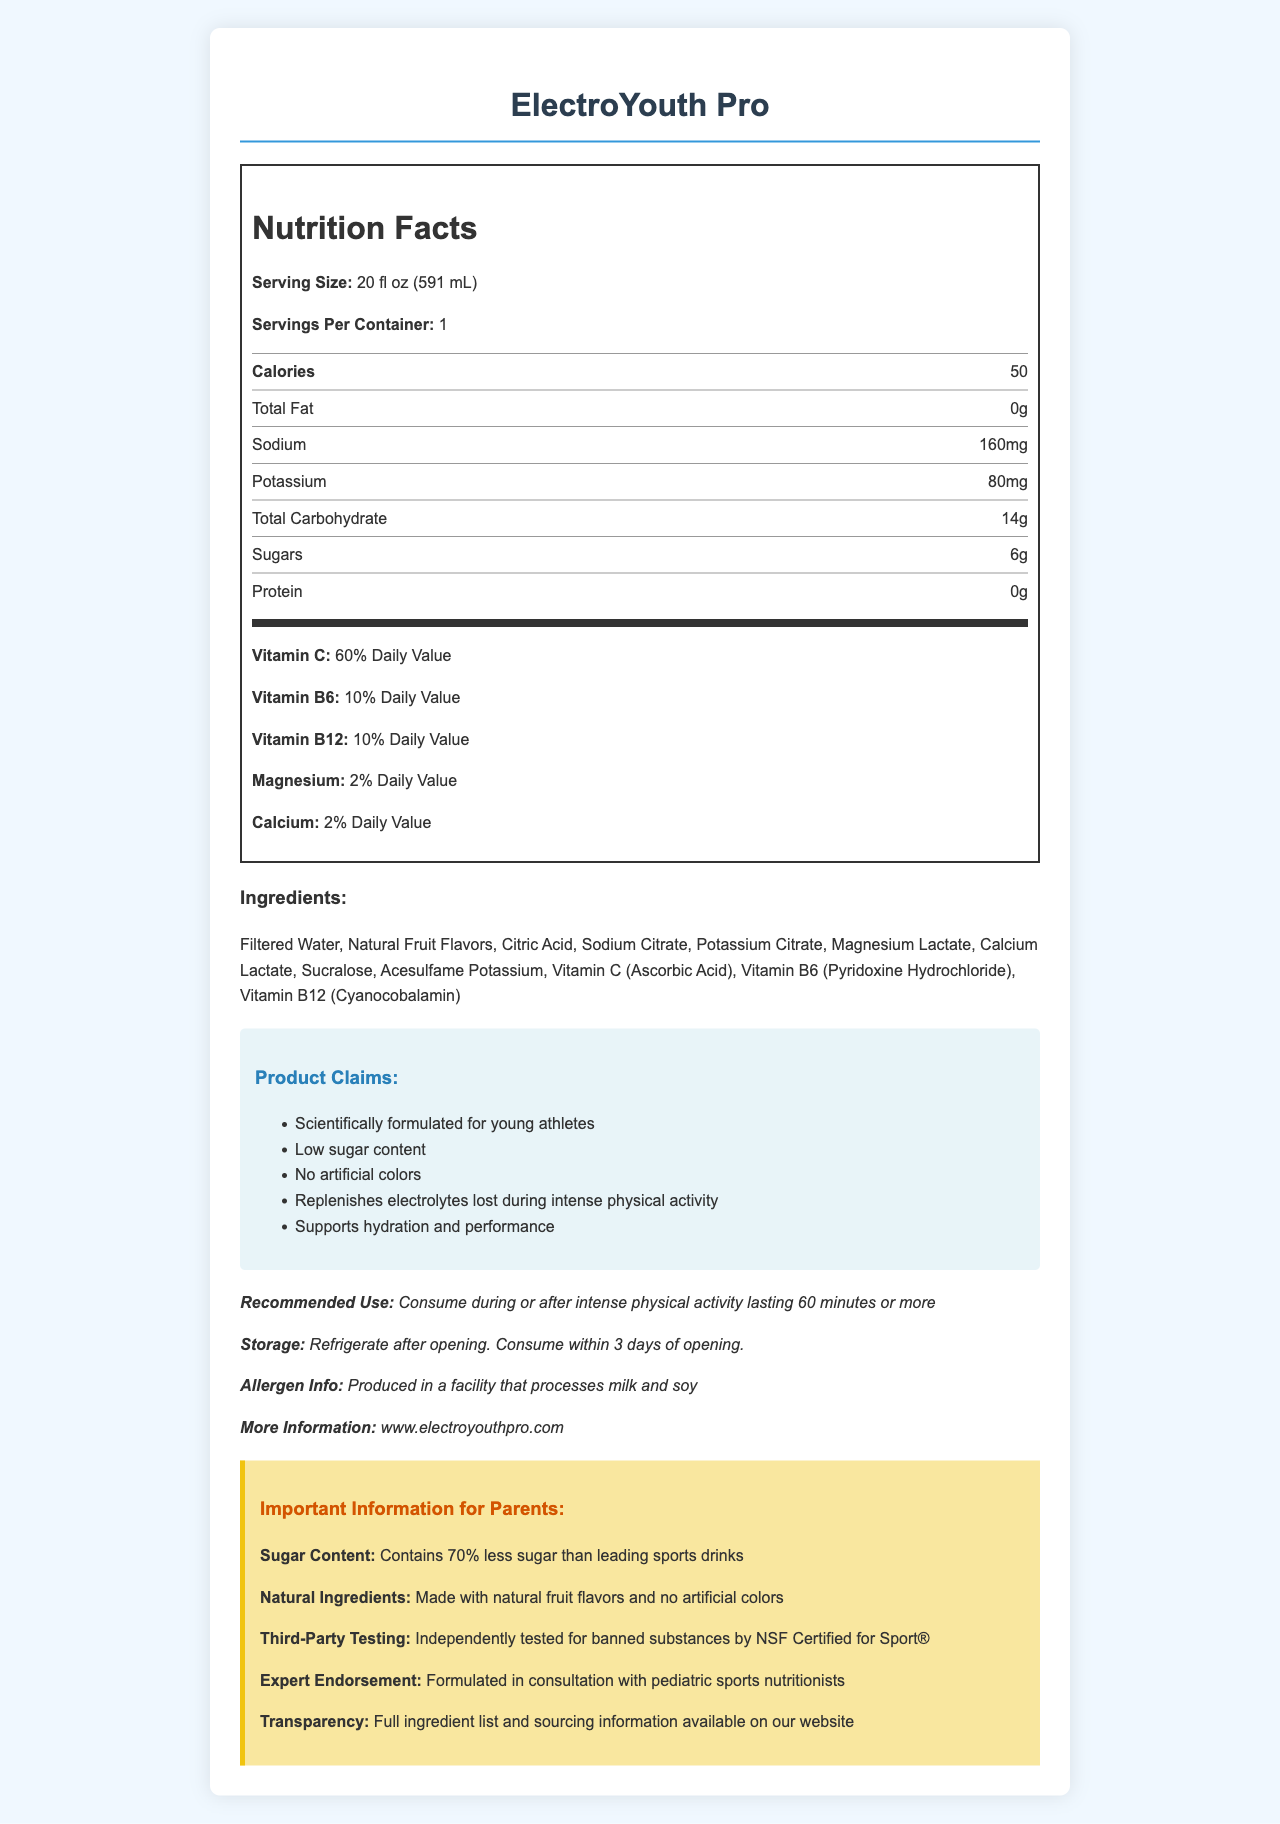what is the serving size? The serving size is listed at the beginning of the nutrition label section.
Answer: 20 fl oz (591 mL) How many servings per container are there? The document specifies that there is 1 serving per container.
Answer: 1 What is the total calorie content per serving? The total calorie content per serving is listed under the nutrition facts section.
Answer: 50 What are the main electrolytes in ElectroYouth Pro? Sodium (160mg) and Potassium (80mg) are listed under the nutrition facts in the nutrition label.
Answer: Sodium and Potassium How much sugar does ElectroYouth Pro contain? The document states that there are 6 grams of sugar per serving.
Answer: 6g What percentage of the daily value of Vitamin C does one serving provide? The Vitamin C content is listed as 60% of the Daily Value in the nutrition facts.
Answer: 60% What is the recommended use for ElectroYouth Pro? The additional information section states the recommended use.
Answer: Consume during or after intense physical activity lasting 60 minutes or more Which of the following ingredients is not present in ElectroYouth Pro? A. Sodium Citrate B. Natural Fruit Flavors C. High Fructose Corn Syrup High Fructose Corn Syrup is not listed in the ingredients section.
Answer: C How many grams of protein does ElectroYouth Pro contain? A. 0g B. 2g C. 5g D. 10g The nutrition facts section lists the protein content as 0 grams.
Answer: A Does ElectroYouth Pro contain any artificial colors? The marketing claims section states that the product contains no artificial colors.
Answer: No Does ElectroYouth Pro have endorsements from pediatric sports nutritionists? The parent-focused details section mentions that the product is formulated in consultation with pediatric sports nutritionists.
Answer: Yes What kind of facility processes this product with respect to allergens? The allergen info in the additional information states that it is produced in a facility that processes milk and soy.
Answer: Processes milk and soy Summarize the main points of the document. The document outlines the product's benefits, nutritional value, ingredients, and specific information targeted towards parents of young athletes.
Answer: ElectroYouth Pro is a sports drink marketed to young athletes. It has low sugar content, provides essential electrolytes like sodium and potassium, and contains vitamins C, B6, and B12. It is made with natural fruit flavors, has no artificial colors, and is vetted by pediatric sports nutritionists. The nutrition label provides details on serving size, calories, and other nutrition information. Marketing claims emphasize hydration, performance, and scientific formulation. What is the purpose of sodium citrate in the ingredients list? The document lists sodium citrate as an ingredient but does not explain its purpose.
Answer: Not enough information 